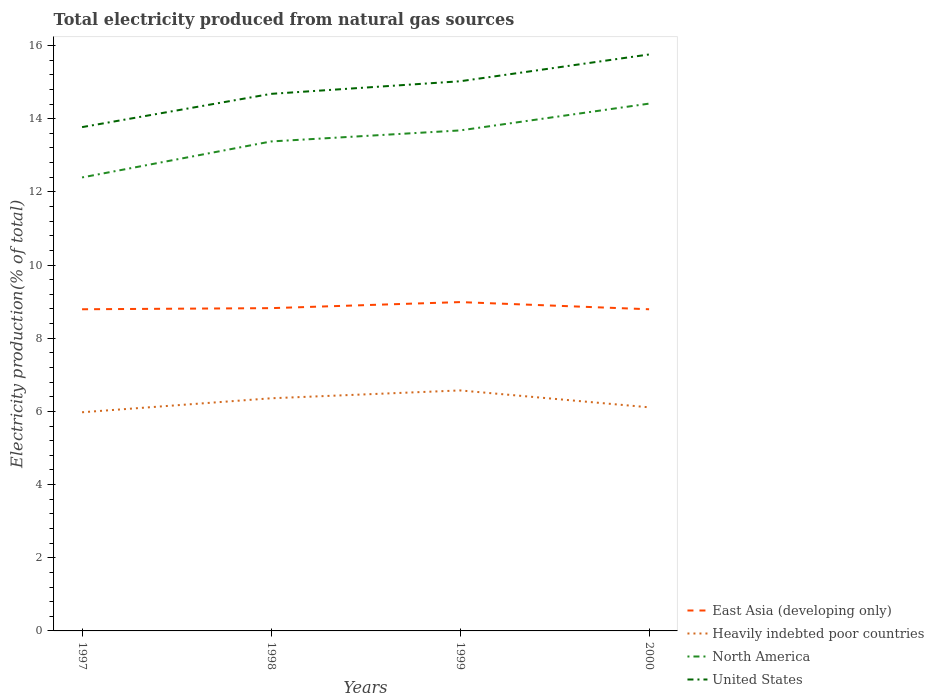Does the line corresponding to United States intersect with the line corresponding to Heavily indebted poor countries?
Offer a terse response. No. Across all years, what is the maximum total electricity produced in United States?
Your answer should be compact. 13.77. What is the total total electricity produced in North America in the graph?
Your response must be concise. -0.73. What is the difference between the highest and the second highest total electricity produced in East Asia (developing only)?
Make the answer very short. 0.2. Where does the legend appear in the graph?
Your answer should be compact. Bottom right. How are the legend labels stacked?
Your response must be concise. Vertical. What is the title of the graph?
Provide a succinct answer. Total electricity produced from natural gas sources. Does "Low income" appear as one of the legend labels in the graph?
Your answer should be compact. No. What is the label or title of the X-axis?
Provide a succinct answer. Years. What is the Electricity production(% of total) of East Asia (developing only) in 1997?
Give a very brief answer. 8.79. What is the Electricity production(% of total) of Heavily indebted poor countries in 1997?
Provide a succinct answer. 5.98. What is the Electricity production(% of total) of North America in 1997?
Provide a succinct answer. 12.39. What is the Electricity production(% of total) in United States in 1997?
Your response must be concise. 13.77. What is the Electricity production(% of total) in East Asia (developing only) in 1998?
Ensure brevity in your answer.  8.82. What is the Electricity production(% of total) in Heavily indebted poor countries in 1998?
Your answer should be very brief. 6.36. What is the Electricity production(% of total) in North America in 1998?
Offer a terse response. 13.38. What is the Electricity production(% of total) in United States in 1998?
Give a very brief answer. 14.68. What is the Electricity production(% of total) of East Asia (developing only) in 1999?
Give a very brief answer. 8.99. What is the Electricity production(% of total) in Heavily indebted poor countries in 1999?
Provide a short and direct response. 6.57. What is the Electricity production(% of total) of North America in 1999?
Offer a terse response. 13.68. What is the Electricity production(% of total) of United States in 1999?
Keep it short and to the point. 15.02. What is the Electricity production(% of total) in East Asia (developing only) in 2000?
Make the answer very short. 8.79. What is the Electricity production(% of total) in Heavily indebted poor countries in 2000?
Ensure brevity in your answer.  6.11. What is the Electricity production(% of total) in North America in 2000?
Provide a succinct answer. 14.41. What is the Electricity production(% of total) of United States in 2000?
Make the answer very short. 15.76. Across all years, what is the maximum Electricity production(% of total) of East Asia (developing only)?
Offer a very short reply. 8.99. Across all years, what is the maximum Electricity production(% of total) of Heavily indebted poor countries?
Offer a very short reply. 6.57. Across all years, what is the maximum Electricity production(% of total) in North America?
Keep it short and to the point. 14.41. Across all years, what is the maximum Electricity production(% of total) of United States?
Give a very brief answer. 15.76. Across all years, what is the minimum Electricity production(% of total) in East Asia (developing only)?
Your answer should be very brief. 8.79. Across all years, what is the minimum Electricity production(% of total) in Heavily indebted poor countries?
Ensure brevity in your answer.  5.98. Across all years, what is the minimum Electricity production(% of total) of North America?
Your answer should be compact. 12.39. Across all years, what is the minimum Electricity production(% of total) of United States?
Give a very brief answer. 13.77. What is the total Electricity production(% of total) in East Asia (developing only) in the graph?
Offer a terse response. 35.39. What is the total Electricity production(% of total) of Heavily indebted poor countries in the graph?
Your response must be concise. 25.02. What is the total Electricity production(% of total) in North America in the graph?
Keep it short and to the point. 53.86. What is the total Electricity production(% of total) of United States in the graph?
Make the answer very short. 59.23. What is the difference between the Electricity production(% of total) in East Asia (developing only) in 1997 and that in 1998?
Give a very brief answer. -0.03. What is the difference between the Electricity production(% of total) in Heavily indebted poor countries in 1997 and that in 1998?
Give a very brief answer. -0.38. What is the difference between the Electricity production(% of total) in North America in 1997 and that in 1998?
Offer a terse response. -0.98. What is the difference between the Electricity production(% of total) of United States in 1997 and that in 1998?
Ensure brevity in your answer.  -0.91. What is the difference between the Electricity production(% of total) in East Asia (developing only) in 1997 and that in 1999?
Keep it short and to the point. -0.2. What is the difference between the Electricity production(% of total) in Heavily indebted poor countries in 1997 and that in 1999?
Provide a short and direct response. -0.6. What is the difference between the Electricity production(% of total) in North America in 1997 and that in 1999?
Make the answer very short. -1.29. What is the difference between the Electricity production(% of total) of United States in 1997 and that in 1999?
Keep it short and to the point. -1.25. What is the difference between the Electricity production(% of total) of East Asia (developing only) in 1997 and that in 2000?
Your response must be concise. -0. What is the difference between the Electricity production(% of total) in Heavily indebted poor countries in 1997 and that in 2000?
Offer a very short reply. -0.14. What is the difference between the Electricity production(% of total) of North America in 1997 and that in 2000?
Keep it short and to the point. -2.02. What is the difference between the Electricity production(% of total) in United States in 1997 and that in 2000?
Keep it short and to the point. -1.99. What is the difference between the Electricity production(% of total) in East Asia (developing only) in 1998 and that in 1999?
Your answer should be very brief. -0.17. What is the difference between the Electricity production(% of total) of Heavily indebted poor countries in 1998 and that in 1999?
Your answer should be compact. -0.21. What is the difference between the Electricity production(% of total) in North America in 1998 and that in 1999?
Keep it short and to the point. -0.3. What is the difference between the Electricity production(% of total) of United States in 1998 and that in 1999?
Keep it short and to the point. -0.34. What is the difference between the Electricity production(% of total) in East Asia (developing only) in 1998 and that in 2000?
Provide a short and direct response. 0.03. What is the difference between the Electricity production(% of total) of Heavily indebted poor countries in 1998 and that in 2000?
Your answer should be very brief. 0.25. What is the difference between the Electricity production(% of total) of North America in 1998 and that in 2000?
Your response must be concise. -1.03. What is the difference between the Electricity production(% of total) in United States in 1998 and that in 2000?
Provide a short and direct response. -1.08. What is the difference between the Electricity production(% of total) of East Asia (developing only) in 1999 and that in 2000?
Keep it short and to the point. 0.2. What is the difference between the Electricity production(% of total) of Heavily indebted poor countries in 1999 and that in 2000?
Ensure brevity in your answer.  0.46. What is the difference between the Electricity production(% of total) in North America in 1999 and that in 2000?
Offer a very short reply. -0.73. What is the difference between the Electricity production(% of total) of United States in 1999 and that in 2000?
Your answer should be very brief. -0.73. What is the difference between the Electricity production(% of total) in East Asia (developing only) in 1997 and the Electricity production(% of total) in Heavily indebted poor countries in 1998?
Provide a succinct answer. 2.43. What is the difference between the Electricity production(% of total) in East Asia (developing only) in 1997 and the Electricity production(% of total) in North America in 1998?
Provide a succinct answer. -4.59. What is the difference between the Electricity production(% of total) of East Asia (developing only) in 1997 and the Electricity production(% of total) of United States in 1998?
Provide a short and direct response. -5.89. What is the difference between the Electricity production(% of total) of Heavily indebted poor countries in 1997 and the Electricity production(% of total) of North America in 1998?
Your answer should be compact. -7.4. What is the difference between the Electricity production(% of total) in Heavily indebted poor countries in 1997 and the Electricity production(% of total) in United States in 1998?
Give a very brief answer. -8.7. What is the difference between the Electricity production(% of total) of North America in 1997 and the Electricity production(% of total) of United States in 1998?
Ensure brevity in your answer.  -2.28. What is the difference between the Electricity production(% of total) of East Asia (developing only) in 1997 and the Electricity production(% of total) of Heavily indebted poor countries in 1999?
Make the answer very short. 2.22. What is the difference between the Electricity production(% of total) of East Asia (developing only) in 1997 and the Electricity production(% of total) of North America in 1999?
Your response must be concise. -4.89. What is the difference between the Electricity production(% of total) in East Asia (developing only) in 1997 and the Electricity production(% of total) in United States in 1999?
Give a very brief answer. -6.23. What is the difference between the Electricity production(% of total) in Heavily indebted poor countries in 1997 and the Electricity production(% of total) in North America in 1999?
Your answer should be compact. -7.7. What is the difference between the Electricity production(% of total) in Heavily indebted poor countries in 1997 and the Electricity production(% of total) in United States in 1999?
Provide a succinct answer. -9.05. What is the difference between the Electricity production(% of total) of North America in 1997 and the Electricity production(% of total) of United States in 1999?
Ensure brevity in your answer.  -2.63. What is the difference between the Electricity production(% of total) of East Asia (developing only) in 1997 and the Electricity production(% of total) of Heavily indebted poor countries in 2000?
Your answer should be very brief. 2.68. What is the difference between the Electricity production(% of total) of East Asia (developing only) in 1997 and the Electricity production(% of total) of North America in 2000?
Keep it short and to the point. -5.62. What is the difference between the Electricity production(% of total) in East Asia (developing only) in 1997 and the Electricity production(% of total) in United States in 2000?
Give a very brief answer. -6.96. What is the difference between the Electricity production(% of total) of Heavily indebted poor countries in 1997 and the Electricity production(% of total) of North America in 2000?
Your answer should be very brief. -8.44. What is the difference between the Electricity production(% of total) in Heavily indebted poor countries in 1997 and the Electricity production(% of total) in United States in 2000?
Make the answer very short. -9.78. What is the difference between the Electricity production(% of total) in North America in 1997 and the Electricity production(% of total) in United States in 2000?
Your answer should be very brief. -3.36. What is the difference between the Electricity production(% of total) in East Asia (developing only) in 1998 and the Electricity production(% of total) in Heavily indebted poor countries in 1999?
Provide a succinct answer. 2.25. What is the difference between the Electricity production(% of total) of East Asia (developing only) in 1998 and the Electricity production(% of total) of North America in 1999?
Your answer should be very brief. -4.86. What is the difference between the Electricity production(% of total) of East Asia (developing only) in 1998 and the Electricity production(% of total) of United States in 1999?
Ensure brevity in your answer.  -6.2. What is the difference between the Electricity production(% of total) of Heavily indebted poor countries in 1998 and the Electricity production(% of total) of North America in 1999?
Provide a short and direct response. -7.32. What is the difference between the Electricity production(% of total) in Heavily indebted poor countries in 1998 and the Electricity production(% of total) in United States in 1999?
Provide a succinct answer. -8.66. What is the difference between the Electricity production(% of total) in North America in 1998 and the Electricity production(% of total) in United States in 1999?
Your answer should be compact. -1.65. What is the difference between the Electricity production(% of total) of East Asia (developing only) in 1998 and the Electricity production(% of total) of Heavily indebted poor countries in 2000?
Give a very brief answer. 2.71. What is the difference between the Electricity production(% of total) of East Asia (developing only) in 1998 and the Electricity production(% of total) of North America in 2000?
Ensure brevity in your answer.  -5.59. What is the difference between the Electricity production(% of total) of East Asia (developing only) in 1998 and the Electricity production(% of total) of United States in 2000?
Provide a short and direct response. -6.93. What is the difference between the Electricity production(% of total) in Heavily indebted poor countries in 1998 and the Electricity production(% of total) in North America in 2000?
Your response must be concise. -8.05. What is the difference between the Electricity production(% of total) of Heavily indebted poor countries in 1998 and the Electricity production(% of total) of United States in 2000?
Make the answer very short. -9.4. What is the difference between the Electricity production(% of total) in North America in 1998 and the Electricity production(% of total) in United States in 2000?
Make the answer very short. -2.38. What is the difference between the Electricity production(% of total) in East Asia (developing only) in 1999 and the Electricity production(% of total) in Heavily indebted poor countries in 2000?
Your response must be concise. 2.88. What is the difference between the Electricity production(% of total) of East Asia (developing only) in 1999 and the Electricity production(% of total) of North America in 2000?
Provide a short and direct response. -5.42. What is the difference between the Electricity production(% of total) of East Asia (developing only) in 1999 and the Electricity production(% of total) of United States in 2000?
Your answer should be very brief. -6.77. What is the difference between the Electricity production(% of total) of Heavily indebted poor countries in 1999 and the Electricity production(% of total) of North America in 2000?
Ensure brevity in your answer.  -7.84. What is the difference between the Electricity production(% of total) of Heavily indebted poor countries in 1999 and the Electricity production(% of total) of United States in 2000?
Offer a terse response. -9.18. What is the difference between the Electricity production(% of total) of North America in 1999 and the Electricity production(% of total) of United States in 2000?
Your answer should be compact. -2.08. What is the average Electricity production(% of total) of East Asia (developing only) per year?
Your answer should be very brief. 8.85. What is the average Electricity production(% of total) of Heavily indebted poor countries per year?
Give a very brief answer. 6.25. What is the average Electricity production(% of total) of North America per year?
Ensure brevity in your answer.  13.47. What is the average Electricity production(% of total) of United States per year?
Your response must be concise. 14.81. In the year 1997, what is the difference between the Electricity production(% of total) in East Asia (developing only) and Electricity production(% of total) in Heavily indebted poor countries?
Offer a very short reply. 2.82. In the year 1997, what is the difference between the Electricity production(% of total) in East Asia (developing only) and Electricity production(% of total) in North America?
Keep it short and to the point. -3.6. In the year 1997, what is the difference between the Electricity production(% of total) of East Asia (developing only) and Electricity production(% of total) of United States?
Offer a terse response. -4.98. In the year 1997, what is the difference between the Electricity production(% of total) in Heavily indebted poor countries and Electricity production(% of total) in North America?
Offer a terse response. -6.42. In the year 1997, what is the difference between the Electricity production(% of total) in Heavily indebted poor countries and Electricity production(% of total) in United States?
Offer a terse response. -7.79. In the year 1997, what is the difference between the Electricity production(% of total) in North America and Electricity production(% of total) in United States?
Provide a succinct answer. -1.38. In the year 1998, what is the difference between the Electricity production(% of total) in East Asia (developing only) and Electricity production(% of total) in Heavily indebted poor countries?
Give a very brief answer. 2.46. In the year 1998, what is the difference between the Electricity production(% of total) in East Asia (developing only) and Electricity production(% of total) in North America?
Your response must be concise. -4.56. In the year 1998, what is the difference between the Electricity production(% of total) of East Asia (developing only) and Electricity production(% of total) of United States?
Keep it short and to the point. -5.86. In the year 1998, what is the difference between the Electricity production(% of total) of Heavily indebted poor countries and Electricity production(% of total) of North America?
Your response must be concise. -7.02. In the year 1998, what is the difference between the Electricity production(% of total) in Heavily indebted poor countries and Electricity production(% of total) in United States?
Make the answer very short. -8.32. In the year 1998, what is the difference between the Electricity production(% of total) of North America and Electricity production(% of total) of United States?
Your answer should be very brief. -1.3. In the year 1999, what is the difference between the Electricity production(% of total) in East Asia (developing only) and Electricity production(% of total) in Heavily indebted poor countries?
Offer a terse response. 2.41. In the year 1999, what is the difference between the Electricity production(% of total) in East Asia (developing only) and Electricity production(% of total) in North America?
Your answer should be very brief. -4.69. In the year 1999, what is the difference between the Electricity production(% of total) of East Asia (developing only) and Electricity production(% of total) of United States?
Make the answer very short. -6.04. In the year 1999, what is the difference between the Electricity production(% of total) in Heavily indebted poor countries and Electricity production(% of total) in North America?
Make the answer very short. -7.11. In the year 1999, what is the difference between the Electricity production(% of total) of Heavily indebted poor countries and Electricity production(% of total) of United States?
Your answer should be compact. -8.45. In the year 1999, what is the difference between the Electricity production(% of total) in North America and Electricity production(% of total) in United States?
Your response must be concise. -1.34. In the year 2000, what is the difference between the Electricity production(% of total) in East Asia (developing only) and Electricity production(% of total) in Heavily indebted poor countries?
Offer a terse response. 2.68. In the year 2000, what is the difference between the Electricity production(% of total) in East Asia (developing only) and Electricity production(% of total) in North America?
Give a very brief answer. -5.62. In the year 2000, what is the difference between the Electricity production(% of total) in East Asia (developing only) and Electricity production(% of total) in United States?
Your answer should be very brief. -6.96. In the year 2000, what is the difference between the Electricity production(% of total) of Heavily indebted poor countries and Electricity production(% of total) of North America?
Make the answer very short. -8.3. In the year 2000, what is the difference between the Electricity production(% of total) of Heavily indebted poor countries and Electricity production(% of total) of United States?
Provide a short and direct response. -9.64. In the year 2000, what is the difference between the Electricity production(% of total) of North America and Electricity production(% of total) of United States?
Provide a succinct answer. -1.34. What is the ratio of the Electricity production(% of total) in Heavily indebted poor countries in 1997 to that in 1998?
Provide a succinct answer. 0.94. What is the ratio of the Electricity production(% of total) in North America in 1997 to that in 1998?
Offer a terse response. 0.93. What is the ratio of the Electricity production(% of total) in United States in 1997 to that in 1998?
Ensure brevity in your answer.  0.94. What is the ratio of the Electricity production(% of total) in East Asia (developing only) in 1997 to that in 1999?
Keep it short and to the point. 0.98. What is the ratio of the Electricity production(% of total) of Heavily indebted poor countries in 1997 to that in 1999?
Make the answer very short. 0.91. What is the ratio of the Electricity production(% of total) in North America in 1997 to that in 1999?
Provide a succinct answer. 0.91. What is the ratio of the Electricity production(% of total) in United States in 1997 to that in 1999?
Your response must be concise. 0.92. What is the ratio of the Electricity production(% of total) in East Asia (developing only) in 1997 to that in 2000?
Offer a very short reply. 1. What is the ratio of the Electricity production(% of total) in Heavily indebted poor countries in 1997 to that in 2000?
Your response must be concise. 0.98. What is the ratio of the Electricity production(% of total) in North America in 1997 to that in 2000?
Ensure brevity in your answer.  0.86. What is the ratio of the Electricity production(% of total) of United States in 1997 to that in 2000?
Provide a succinct answer. 0.87. What is the ratio of the Electricity production(% of total) in East Asia (developing only) in 1998 to that in 1999?
Provide a succinct answer. 0.98. What is the ratio of the Electricity production(% of total) of Heavily indebted poor countries in 1998 to that in 1999?
Keep it short and to the point. 0.97. What is the ratio of the Electricity production(% of total) of North America in 1998 to that in 1999?
Keep it short and to the point. 0.98. What is the ratio of the Electricity production(% of total) of United States in 1998 to that in 1999?
Ensure brevity in your answer.  0.98. What is the ratio of the Electricity production(% of total) in Heavily indebted poor countries in 1998 to that in 2000?
Offer a very short reply. 1.04. What is the ratio of the Electricity production(% of total) of North America in 1998 to that in 2000?
Your response must be concise. 0.93. What is the ratio of the Electricity production(% of total) in United States in 1998 to that in 2000?
Your answer should be very brief. 0.93. What is the ratio of the Electricity production(% of total) in East Asia (developing only) in 1999 to that in 2000?
Offer a terse response. 1.02. What is the ratio of the Electricity production(% of total) of Heavily indebted poor countries in 1999 to that in 2000?
Ensure brevity in your answer.  1.08. What is the ratio of the Electricity production(% of total) in North America in 1999 to that in 2000?
Your answer should be very brief. 0.95. What is the ratio of the Electricity production(% of total) in United States in 1999 to that in 2000?
Offer a terse response. 0.95. What is the difference between the highest and the second highest Electricity production(% of total) of East Asia (developing only)?
Keep it short and to the point. 0.17. What is the difference between the highest and the second highest Electricity production(% of total) in Heavily indebted poor countries?
Keep it short and to the point. 0.21. What is the difference between the highest and the second highest Electricity production(% of total) in North America?
Provide a succinct answer. 0.73. What is the difference between the highest and the second highest Electricity production(% of total) of United States?
Provide a short and direct response. 0.73. What is the difference between the highest and the lowest Electricity production(% of total) of East Asia (developing only)?
Your response must be concise. 0.2. What is the difference between the highest and the lowest Electricity production(% of total) in Heavily indebted poor countries?
Make the answer very short. 0.6. What is the difference between the highest and the lowest Electricity production(% of total) of North America?
Provide a short and direct response. 2.02. What is the difference between the highest and the lowest Electricity production(% of total) in United States?
Keep it short and to the point. 1.99. 